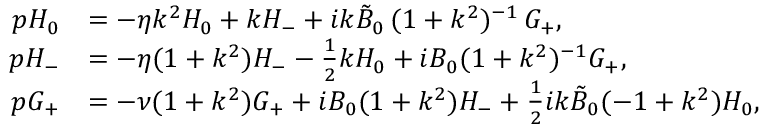Convert formula to latex. <formula><loc_0><loc_0><loc_500><loc_500>\begin{array} { r l } { p H _ { 0 } } & { = - \eta k ^ { 2 } H _ { 0 } + k H _ { - } + i k \tilde { B } _ { 0 } \, ( 1 + k ^ { 2 } ) ^ { - 1 } \, G _ { + } , } \\ { p H _ { - } } & { = - \eta ( 1 + k ^ { 2 } ) H _ { - } - \frac { 1 } { 2 } k H _ { 0 } + i B _ { 0 } ( 1 + k ^ { 2 } ) ^ { - 1 } G _ { + } , } \\ { p G _ { + } } & { = - \nu ( 1 + k ^ { 2 } ) G _ { + } + i B _ { 0 } ( 1 + k ^ { 2 } ) H _ { - } + \frac { 1 } { 2 } { i k \tilde { B } _ { 0 } } ( - 1 + k ^ { 2 } ) H _ { 0 } , } \end{array}</formula> 